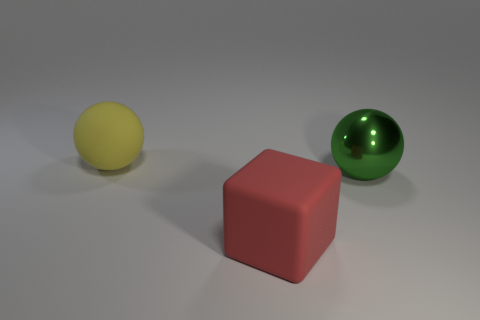Is the number of large objects that are to the right of the green shiny ball less than the number of big spheres in front of the yellow ball?
Make the answer very short. Yes. There is a thing that is in front of the yellow thing and behind the big block; what is its shape?
Your response must be concise. Sphere. What number of other big things are the same shape as the large red rubber object?
Provide a succinct answer. 0. What size is the other object that is the same material as the large yellow thing?
Offer a terse response. Large. How many other cubes are the same size as the cube?
Make the answer very short. 0. There is a matte thing in front of the big sphere left of the large red thing; what is its color?
Offer a very short reply. Red. Are there any other large shiny balls of the same color as the shiny sphere?
Your response must be concise. No. What color is the sphere that is the same size as the yellow thing?
Provide a short and direct response. Green. Is the material of the thing that is in front of the green metallic ball the same as the green sphere?
Your answer should be compact. No. Are there any large cubes right of the matte object that is in front of the big thing behind the large green sphere?
Your answer should be compact. No. 